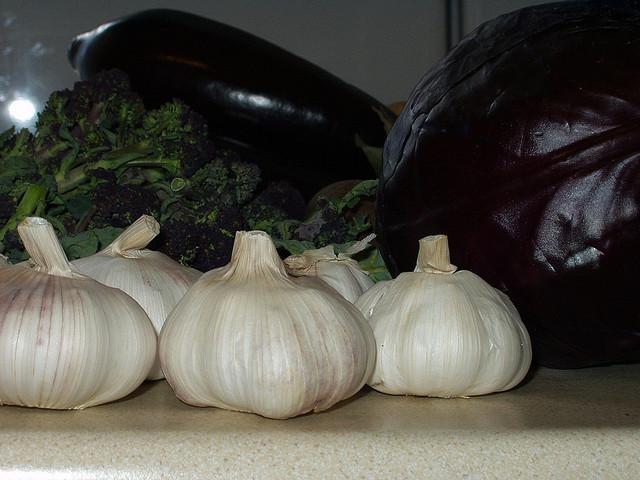Is there any fruit in this picture?
Write a very short answer. No. How many garlic bulbs are there?
Give a very brief answer. 5. Is there broccoli in this photo?
Write a very short answer. Yes. 